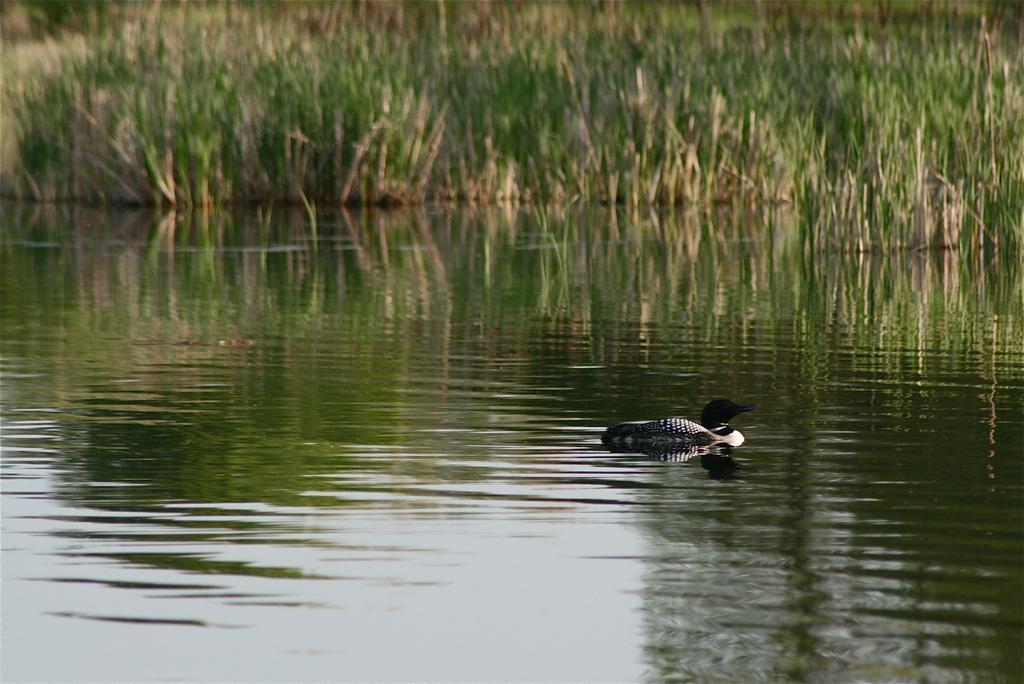How would you summarize this image in a sentence or two? In this image, we can see water, at the right side there is an animal swimming in the water, we can see some green color grass. 